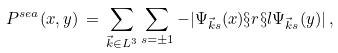Convert formula to latex. <formula><loc_0><loc_0><loc_500><loc_500>P ^ { s e a } ( x , y ) \, = \, \sum _ { \vec { k } \in L ^ { 3 } } \sum _ { s = \pm 1 } - | \Psi _ { \vec { k } s } ( x ) \S r \S l \Psi _ { \vec { k } s } ( y ) | \, ,</formula> 